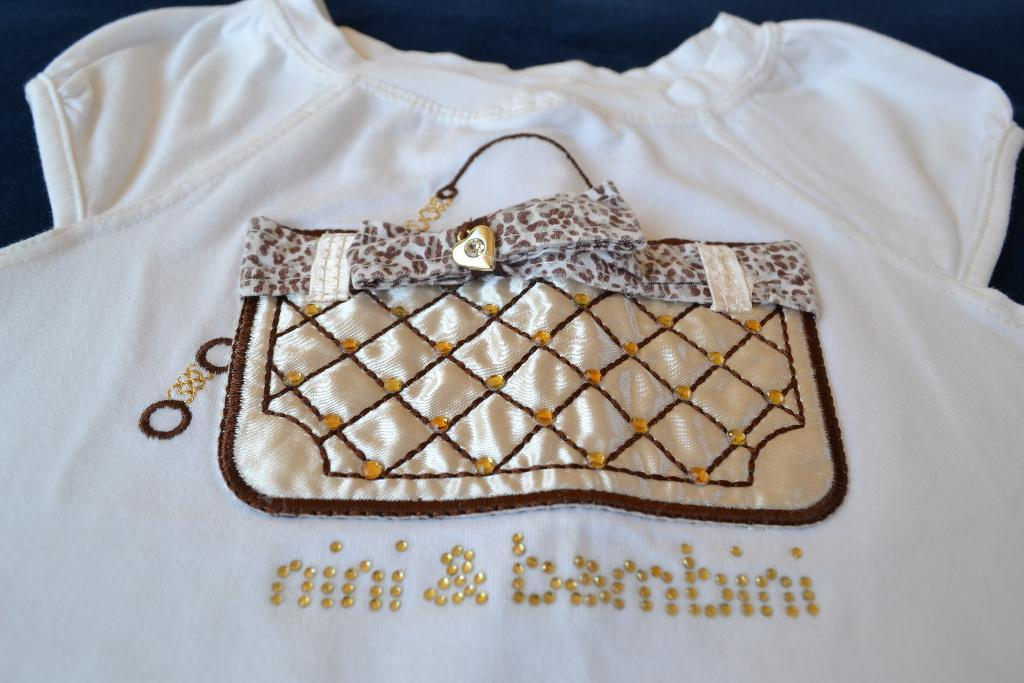What color is the dress in the picture? The dress in the picture is white. Does the dress have any specific features or patterns? Yes, the dress has a design. Is there any text or writing on the dress? Yes, there is something written on the dress. How low does the sponge hang from the dress in the image? There is no sponge present in the image, so it cannot be determined how low it might hang from the dress. 